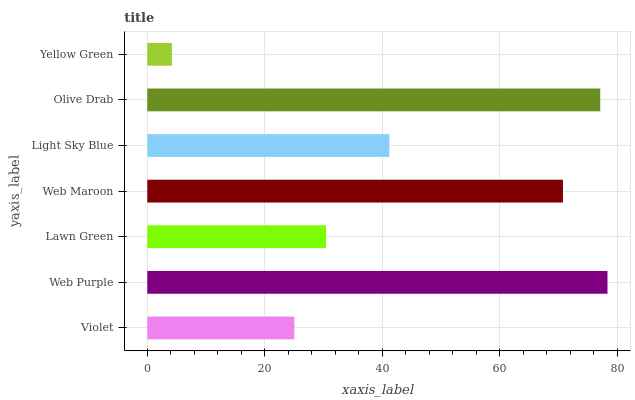Is Yellow Green the minimum?
Answer yes or no. Yes. Is Web Purple the maximum?
Answer yes or no. Yes. Is Lawn Green the minimum?
Answer yes or no. No. Is Lawn Green the maximum?
Answer yes or no. No. Is Web Purple greater than Lawn Green?
Answer yes or no. Yes. Is Lawn Green less than Web Purple?
Answer yes or no. Yes. Is Lawn Green greater than Web Purple?
Answer yes or no. No. Is Web Purple less than Lawn Green?
Answer yes or no. No. Is Light Sky Blue the high median?
Answer yes or no. Yes. Is Light Sky Blue the low median?
Answer yes or no. Yes. Is Yellow Green the high median?
Answer yes or no. No. Is Yellow Green the low median?
Answer yes or no. No. 